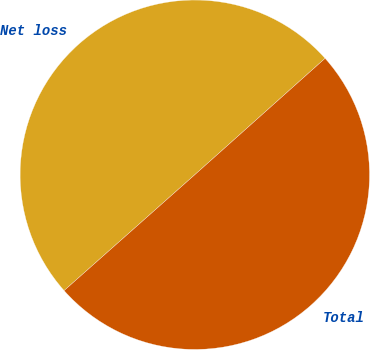<chart> <loc_0><loc_0><loc_500><loc_500><pie_chart><fcel>Net loss<fcel>Total<nl><fcel>49.94%<fcel>50.06%<nl></chart> 